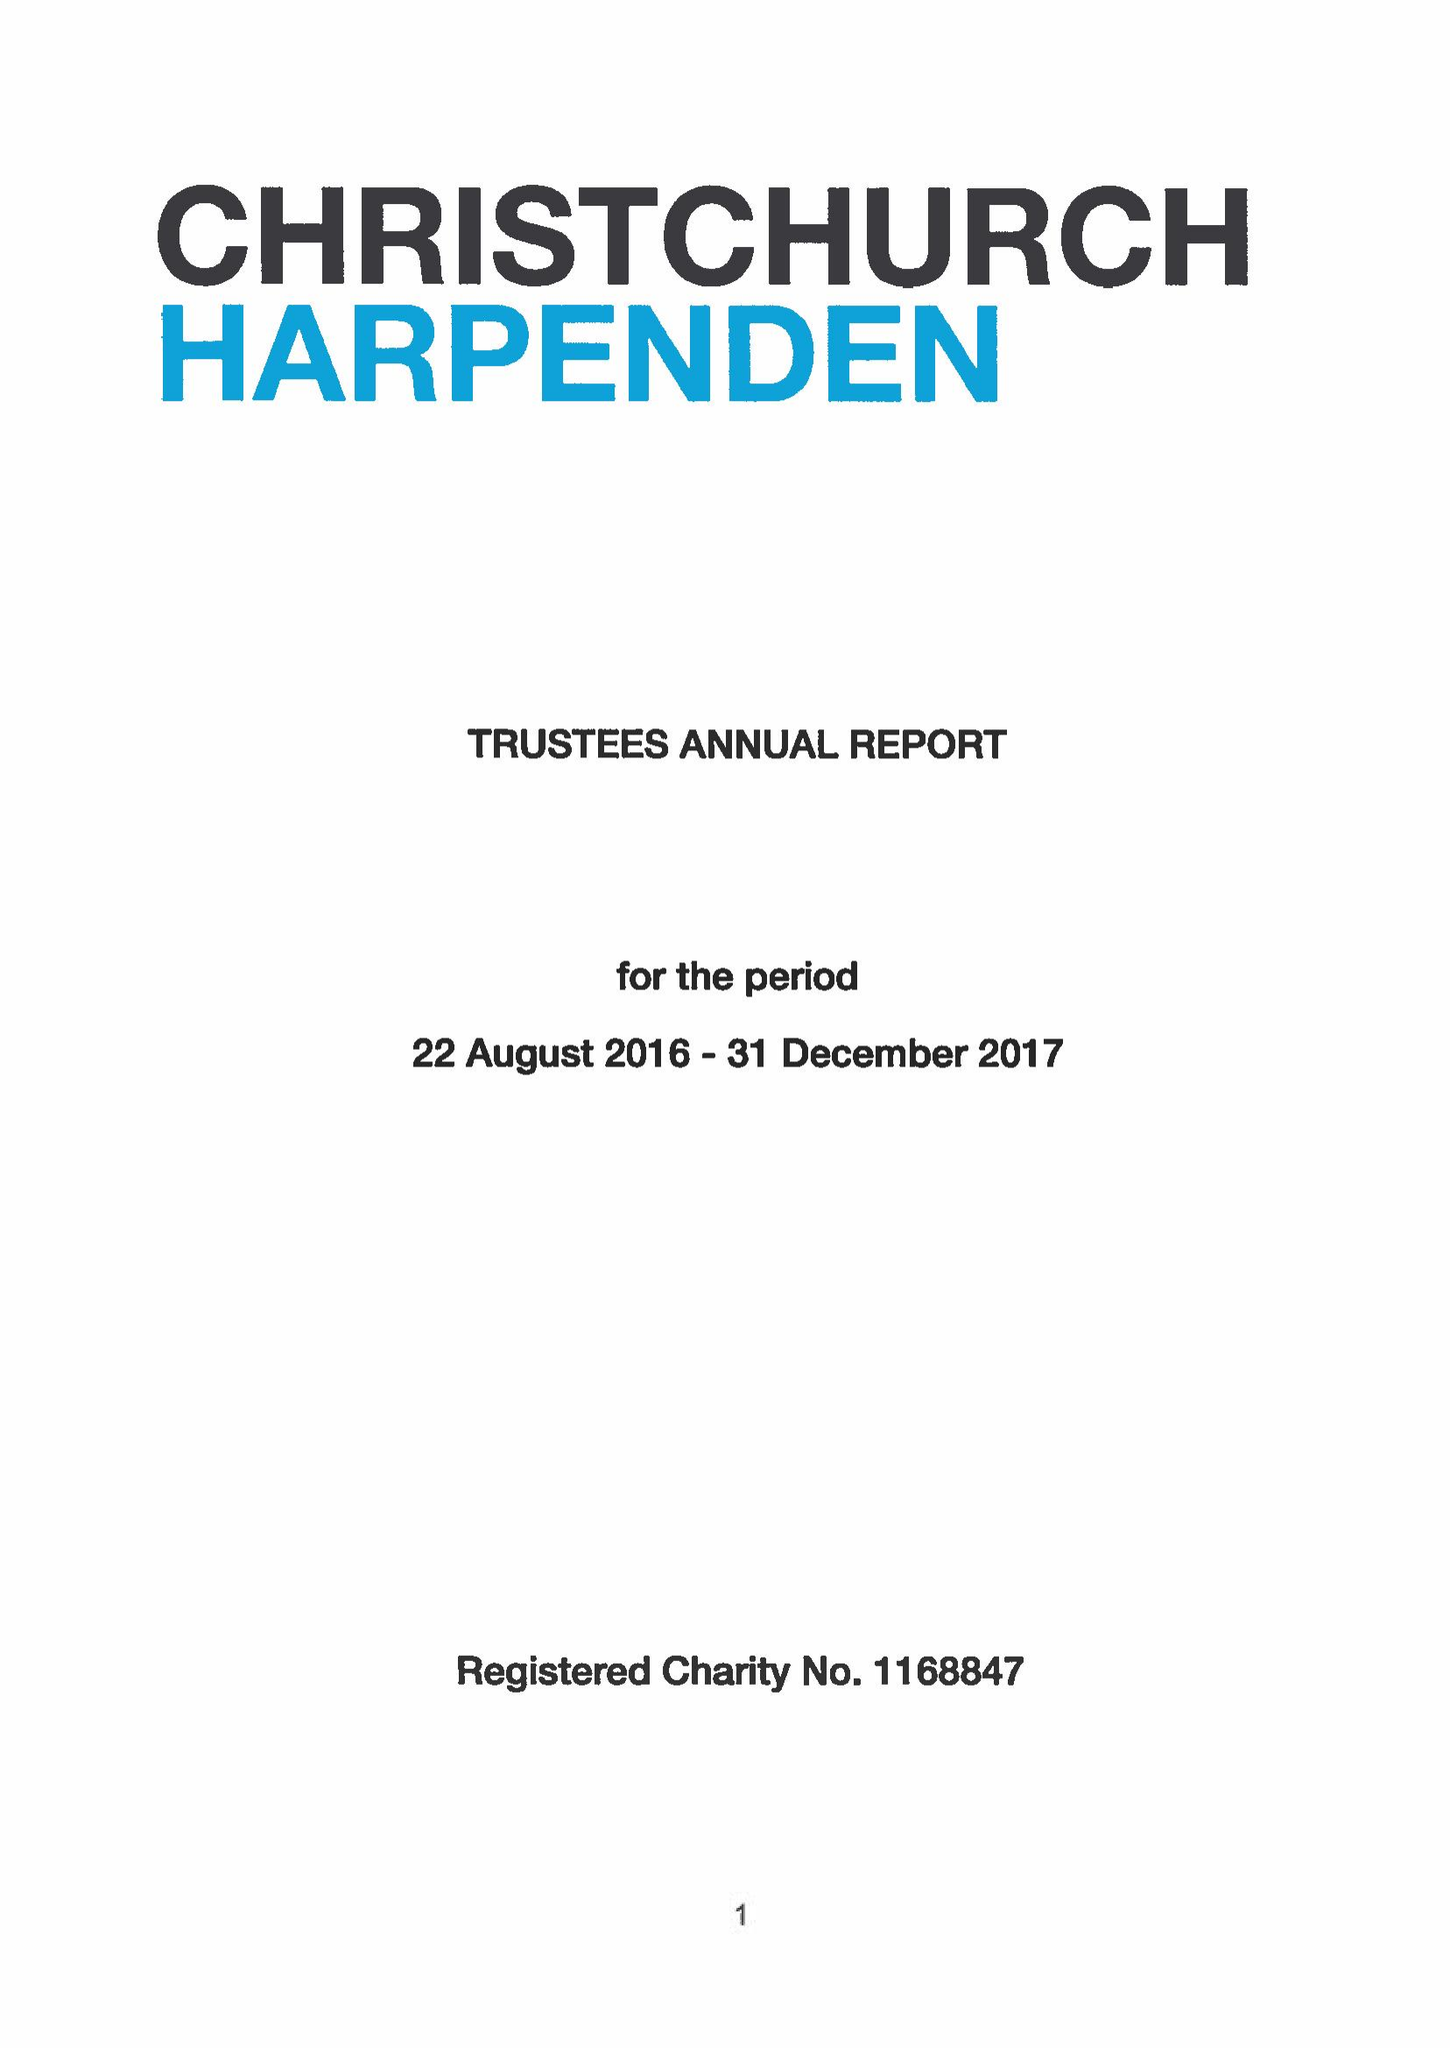What is the value for the income_annually_in_british_pounds?
Answer the question using a single word or phrase. 417620.00 